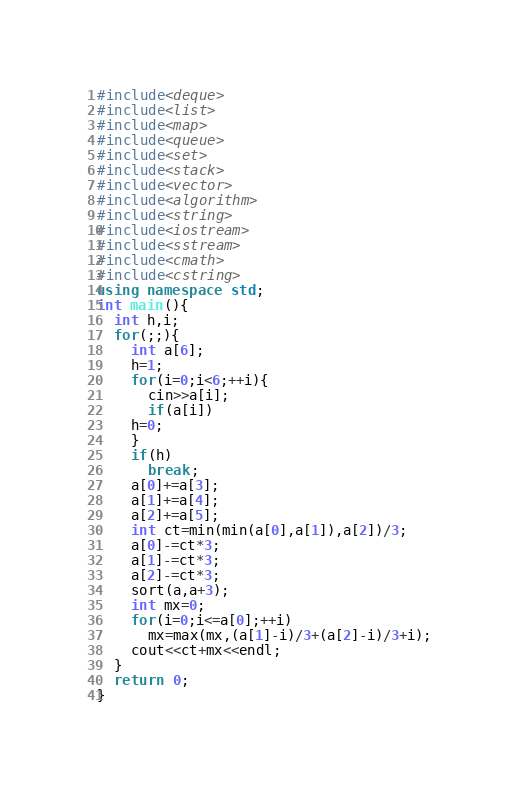<code> <loc_0><loc_0><loc_500><loc_500><_C++_>#include<deque>
#include<list>
#include<map>
#include<queue>
#include<set>
#include<stack>
#include<vector>
#include<algorithm>
#include<string>
#include<iostream>
#include<sstream>
#include<cmath>
#include<cstring>
using namespace std;
int main(){
  int h,i;
  for(;;){
    int a[6];
    h=1;
    for(i=0;i<6;++i){
      cin>>a[i];
      if(a[i])
	h=0;
    }
    if(h)
      break;
    a[0]+=a[3];
    a[1]+=a[4];
    a[2]+=a[5];
    int ct=min(min(a[0],a[1]),a[2])/3;
    a[0]-=ct*3;
    a[1]-=ct*3;
    a[2]-=ct*3;
    sort(a,a+3);
    int mx=0;
    for(i=0;i<=a[0];++i)
      mx=max(mx,(a[1]-i)/3+(a[2]-i)/3+i);
    cout<<ct+mx<<endl;
  }
  return 0;
}</code> 